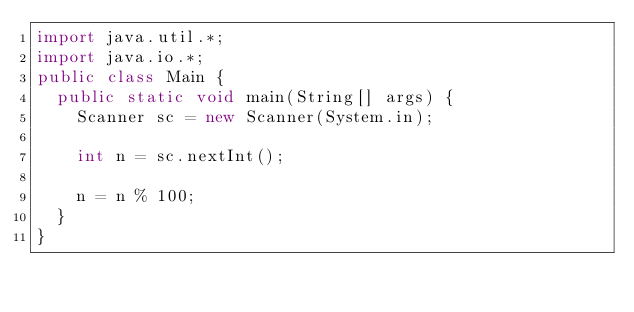Convert code to text. <code><loc_0><loc_0><loc_500><loc_500><_Java_>import java.util.*;
import java.io.*;
public class Main {
	public static void main(String[] args) {
		Scanner sc = new Scanner(System.in);
	
		int n = sc.nextInt();

		n = n % 100;
	}
}
</code> 